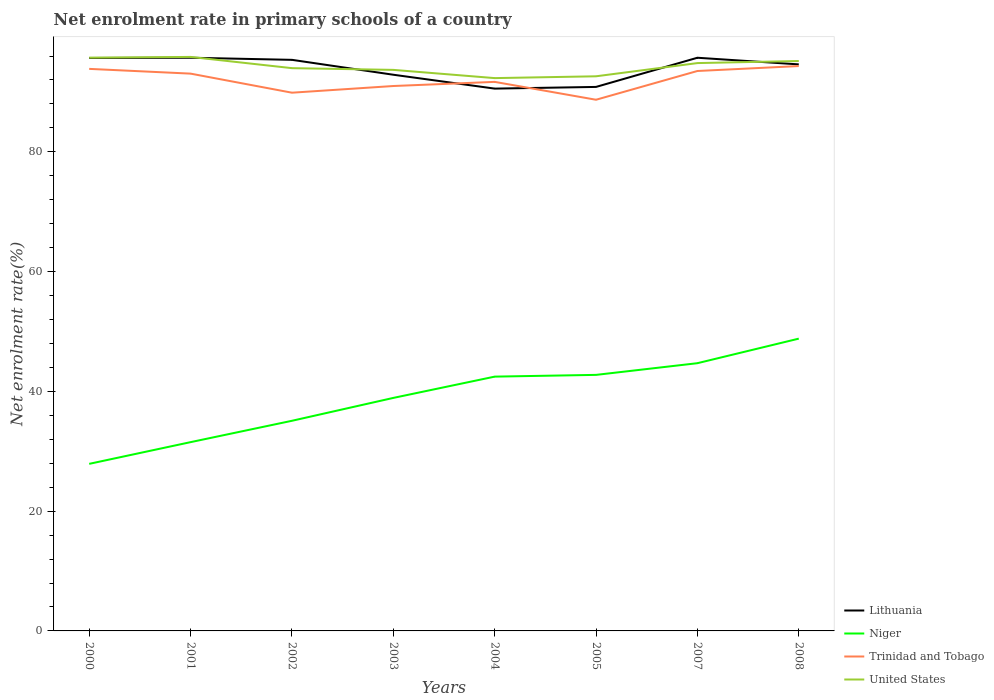Is the number of lines equal to the number of legend labels?
Your answer should be compact. Yes. Across all years, what is the maximum net enrolment rate in primary schools in Niger?
Make the answer very short. 27.9. What is the total net enrolment rate in primary schools in Trinidad and Tobago in the graph?
Ensure brevity in your answer.  -0.69. What is the difference between the highest and the second highest net enrolment rate in primary schools in United States?
Your answer should be very brief. 3.54. What is the difference between the highest and the lowest net enrolment rate in primary schools in Trinidad and Tobago?
Make the answer very short. 4. Is the net enrolment rate in primary schools in Lithuania strictly greater than the net enrolment rate in primary schools in United States over the years?
Offer a very short reply. No. What is the difference between two consecutive major ticks on the Y-axis?
Offer a very short reply. 20. Where does the legend appear in the graph?
Keep it short and to the point. Bottom right. How many legend labels are there?
Keep it short and to the point. 4. What is the title of the graph?
Provide a succinct answer. Net enrolment rate in primary schools of a country. Does "South Asia" appear as one of the legend labels in the graph?
Your answer should be compact. No. What is the label or title of the X-axis?
Provide a succinct answer. Years. What is the label or title of the Y-axis?
Give a very brief answer. Net enrolment rate(%). What is the Net enrolment rate(%) of Lithuania in 2000?
Make the answer very short. 95.68. What is the Net enrolment rate(%) in Niger in 2000?
Provide a succinct answer. 27.9. What is the Net enrolment rate(%) of Trinidad and Tobago in 2000?
Provide a succinct answer. 93.86. What is the Net enrolment rate(%) of United States in 2000?
Ensure brevity in your answer.  95.73. What is the Net enrolment rate(%) in Lithuania in 2001?
Offer a terse response. 95.72. What is the Net enrolment rate(%) in Niger in 2001?
Your answer should be compact. 31.52. What is the Net enrolment rate(%) of Trinidad and Tobago in 2001?
Ensure brevity in your answer.  93.06. What is the Net enrolment rate(%) of United States in 2001?
Offer a very short reply. 95.85. What is the Net enrolment rate(%) of Lithuania in 2002?
Your response must be concise. 95.37. What is the Net enrolment rate(%) in Niger in 2002?
Your answer should be compact. 35.09. What is the Net enrolment rate(%) of Trinidad and Tobago in 2002?
Provide a succinct answer. 89.88. What is the Net enrolment rate(%) in United States in 2002?
Offer a terse response. 93.98. What is the Net enrolment rate(%) of Lithuania in 2003?
Give a very brief answer. 92.88. What is the Net enrolment rate(%) of Niger in 2003?
Your answer should be very brief. 38.91. What is the Net enrolment rate(%) in Trinidad and Tobago in 2003?
Your answer should be compact. 90.99. What is the Net enrolment rate(%) of United States in 2003?
Your answer should be compact. 93.69. What is the Net enrolment rate(%) in Lithuania in 2004?
Provide a succinct answer. 90.56. What is the Net enrolment rate(%) in Niger in 2004?
Provide a succinct answer. 42.46. What is the Net enrolment rate(%) of Trinidad and Tobago in 2004?
Your response must be concise. 91.68. What is the Net enrolment rate(%) of United States in 2004?
Give a very brief answer. 92.31. What is the Net enrolment rate(%) of Lithuania in 2005?
Offer a very short reply. 90.84. What is the Net enrolment rate(%) of Niger in 2005?
Give a very brief answer. 42.76. What is the Net enrolment rate(%) of Trinidad and Tobago in 2005?
Ensure brevity in your answer.  88.7. What is the Net enrolment rate(%) of United States in 2005?
Make the answer very short. 92.62. What is the Net enrolment rate(%) of Lithuania in 2007?
Keep it short and to the point. 95.71. What is the Net enrolment rate(%) in Niger in 2007?
Your response must be concise. 44.71. What is the Net enrolment rate(%) in Trinidad and Tobago in 2007?
Make the answer very short. 93.5. What is the Net enrolment rate(%) of United States in 2007?
Make the answer very short. 94.82. What is the Net enrolment rate(%) of Lithuania in 2008?
Keep it short and to the point. 94.61. What is the Net enrolment rate(%) in Niger in 2008?
Make the answer very short. 48.81. What is the Net enrolment rate(%) in Trinidad and Tobago in 2008?
Offer a terse response. 94.33. What is the Net enrolment rate(%) of United States in 2008?
Your answer should be very brief. 95.17. Across all years, what is the maximum Net enrolment rate(%) in Lithuania?
Provide a succinct answer. 95.72. Across all years, what is the maximum Net enrolment rate(%) of Niger?
Provide a succinct answer. 48.81. Across all years, what is the maximum Net enrolment rate(%) in Trinidad and Tobago?
Offer a terse response. 94.33. Across all years, what is the maximum Net enrolment rate(%) of United States?
Your answer should be compact. 95.85. Across all years, what is the minimum Net enrolment rate(%) of Lithuania?
Provide a succinct answer. 90.56. Across all years, what is the minimum Net enrolment rate(%) of Niger?
Give a very brief answer. 27.9. Across all years, what is the minimum Net enrolment rate(%) in Trinidad and Tobago?
Offer a very short reply. 88.7. Across all years, what is the minimum Net enrolment rate(%) in United States?
Offer a very short reply. 92.31. What is the total Net enrolment rate(%) of Lithuania in the graph?
Keep it short and to the point. 751.36. What is the total Net enrolment rate(%) in Niger in the graph?
Make the answer very short. 312.16. What is the total Net enrolment rate(%) of Trinidad and Tobago in the graph?
Your answer should be very brief. 736.01. What is the total Net enrolment rate(%) in United States in the graph?
Offer a very short reply. 754.18. What is the difference between the Net enrolment rate(%) in Lithuania in 2000 and that in 2001?
Offer a terse response. -0.04. What is the difference between the Net enrolment rate(%) of Niger in 2000 and that in 2001?
Your answer should be very brief. -3.62. What is the difference between the Net enrolment rate(%) of Trinidad and Tobago in 2000 and that in 2001?
Give a very brief answer. 0.79. What is the difference between the Net enrolment rate(%) in United States in 2000 and that in 2001?
Offer a terse response. -0.12. What is the difference between the Net enrolment rate(%) in Lithuania in 2000 and that in 2002?
Make the answer very short. 0.31. What is the difference between the Net enrolment rate(%) in Niger in 2000 and that in 2002?
Keep it short and to the point. -7.19. What is the difference between the Net enrolment rate(%) in Trinidad and Tobago in 2000 and that in 2002?
Provide a short and direct response. 3.98. What is the difference between the Net enrolment rate(%) in United States in 2000 and that in 2002?
Keep it short and to the point. 1.75. What is the difference between the Net enrolment rate(%) of Lithuania in 2000 and that in 2003?
Give a very brief answer. 2.8. What is the difference between the Net enrolment rate(%) in Niger in 2000 and that in 2003?
Your response must be concise. -11.01. What is the difference between the Net enrolment rate(%) of Trinidad and Tobago in 2000 and that in 2003?
Provide a succinct answer. 2.86. What is the difference between the Net enrolment rate(%) of United States in 2000 and that in 2003?
Your answer should be very brief. 2.04. What is the difference between the Net enrolment rate(%) of Lithuania in 2000 and that in 2004?
Your response must be concise. 5.11. What is the difference between the Net enrolment rate(%) in Niger in 2000 and that in 2004?
Provide a succinct answer. -14.57. What is the difference between the Net enrolment rate(%) in Trinidad and Tobago in 2000 and that in 2004?
Your answer should be very brief. 2.17. What is the difference between the Net enrolment rate(%) of United States in 2000 and that in 2004?
Your answer should be compact. 3.41. What is the difference between the Net enrolment rate(%) of Lithuania in 2000 and that in 2005?
Make the answer very short. 4.83. What is the difference between the Net enrolment rate(%) of Niger in 2000 and that in 2005?
Your response must be concise. -14.86. What is the difference between the Net enrolment rate(%) of Trinidad and Tobago in 2000 and that in 2005?
Provide a short and direct response. 5.16. What is the difference between the Net enrolment rate(%) in United States in 2000 and that in 2005?
Your answer should be compact. 3.11. What is the difference between the Net enrolment rate(%) of Lithuania in 2000 and that in 2007?
Your answer should be compact. -0.04. What is the difference between the Net enrolment rate(%) of Niger in 2000 and that in 2007?
Provide a short and direct response. -16.81. What is the difference between the Net enrolment rate(%) of Trinidad and Tobago in 2000 and that in 2007?
Your response must be concise. 0.35. What is the difference between the Net enrolment rate(%) of United States in 2000 and that in 2007?
Provide a succinct answer. 0.91. What is the difference between the Net enrolment rate(%) of Lithuania in 2000 and that in 2008?
Provide a short and direct response. 1.07. What is the difference between the Net enrolment rate(%) of Niger in 2000 and that in 2008?
Offer a terse response. -20.91. What is the difference between the Net enrolment rate(%) in Trinidad and Tobago in 2000 and that in 2008?
Your response must be concise. -0.47. What is the difference between the Net enrolment rate(%) of United States in 2000 and that in 2008?
Offer a terse response. 0.56. What is the difference between the Net enrolment rate(%) in Lithuania in 2001 and that in 2002?
Provide a short and direct response. 0.35. What is the difference between the Net enrolment rate(%) in Niger in 2001 and that in 2002?
Make the answer very short. -3.57. What is the difference between the Net enrolment rate(%) of Trinidad and Tobago in 2001 and that in 2002?
Your response must be concise. 3.18. What is the difference between the Net enrolment rate(%) of United States in 2001 and that in 2002?
Make the answer very short. 1.88. What is the difference between the Net enrolment rate(%) of Lithuania in 2001 and that in 2003?
Your response must be concise. 2.84. What is the difference between the Net enrolment rate(%) of Niger in 2001 and that in 2003?
Your answer should be compact. -7.39. What is the difference between the Net enrolment rate(%) of Trinidad and Tobago in 2001 and that in 2003?
Provide a succinct answer. 2.07. What is the difference between the Net enrolment rate(%) of United States in 2001 and that in 2003?
Provide a succinct answer. 2.16. What is the difference between the Net enrolment rate(%) of Lithuania in 2001 and that in 2004?
Your response must be concise. 5.16. What is the difference between the Net enrolment rate(%) of Niger in 2001 and that in 2004?
Your response must be concise. -10.94. What is the difference between the Net enrolment rate(%) of Trinidad and Tobago in 2001 and that in 2004?
Make the answer very short. 1.38. What is the difference between the Net enrolment rate(%) of United States in 2001 and that in 2004?
Your answer should be very brief. 3.54. What is the difference between the Net enrolment rate(%) of Lithuania in 2001 and that in 2005?
Give a very brief answer. 4.87. What is the difference between the Net enrolment rate(%) of Niger in 2001 and that in 2005?
Offer a very short reply. -11.23. What is the difference between the Net enrolment rate(%) in Trinidad and Tobago in 2001 and that in 2005?
Keep it short and to the point. 4.36. What is the difference between the Net enrolment rate(%) of United States in 2001 and that in 2005?
Your response must be concise. 3.23. What is the difference between the Net enrolment rate(%) of Lithuania in 2001 and that in 2007?
Make the answer very short. 0. What is the difference between the Net enrolment rate(%) of Niger in 2001 and that in 2007?
Your answer should be very brief. -13.19. What is the difference between the Net enrolment rate(%) of Trinidad and Tobago in 2001 and that in 2007?
Your response must be concise. -0.44. What is the difference between the Net enrolment rate(%) of United States in 2001 and that in 2007?
Provide a succinct answer. 1.03. What is the difference between the Net enrolment rate(%) of Lithuania in 2001 and that in 2008?
Give a very brief answer. 1.11. What is the difference between the Net enrolment rate(%) of Niger in 2001 and that in 2008?
Your answer should be very brief. -17.29. What is the difference between the Net enrolment rate(%) of Trinidad and Tobago in 2001 and that in 2008?
Provide a short and direct response. -1.27. What is the difference between the Net enrolment rate(%) of United States in 2001 and that in 2008?
Provide a short and direct response. 0.68. What is the difference between the Net enrolment rate(%) in Lithuania in 2002 and that in 2003?
Provide a succinct answer. 2.49. What is the difference between the Net enrolment rate(%) of Niger in 2002 and that in 2003?
Provide a succinct answer. -3.82. What is the difference between the Net enrolment rate(%) of Trinidad and Tobago in 2002 and that in 2003?
Ensure brevity in your answer.  -1.12. What is the difference between the Net enrolment rate(%) of United States in 2002 and that in 2003?
Keep it short and to the point. 0.29. What is the difference between the Net enrolment rate(%) of Lithuania in 2002 and that in 2004?
Offer a terse response. 4.8. What is the difference between the Net enrolment rate(%) in Niger in 2002 and that in 2004?
Your answer should be compact. -7.37. What is the difference between the Net enrolment rate(%) in Trinidad and Tobago in 2002 and that in 2004?
Keep it short and to the point. -1.81. What is the difference between the Net enrolment rate(%) of United States in 2002 and that in 2004?
Your response must be concise. 1.66. What is the difference between the Net enrolment rate(%) of Lithuania in 2002 and that in 2005?
Your response must be concise. 4.52. What is the difference between the Net enrolment rate(%) in Niger in 2002 and that in 2005?
Your answer should be very brief. -7.67. What is the difference between the Net enrolment rate(%) in Trinidad and Tobago in 2002 and that in 2005?
Your answer should be very brief. 1.18. What is the difference between the Net enrolment rate(%) of United States in 2002 and that in 2005?
Your response must be concise. 1.36. What is the difference between the Net enrolment rate(%) of Lithuania in 2002 and that in 2007?
Your answer should be very brief. -0.35. What is the difference between the Net enrolment rate(%) of Niger in 2002 and that in 2007?
Give a very brief answer. -9.62. What is the difference between the Net enrolment rate(%) of Trinidad and Tobago in 2002 and that in 2007?
Your response must be concise. -3.62. What is the difference between the Net enrolment rate(%) in United States in 2002 and that in 2007?
Offer a very short reply. -0.85. What is the difference between the Net enrolment rate(%) of Lithuania in 2002 and that in 2008?
Ensure brevity in your answer.  0.76. What is the difference between the Net enrolment rate(%) of Niger in 2002 and that in 2008?
Keep it short and to the point. -13.72. What is the difference between the Net enrolment rate(%) in Trinidad and Tobago in 2002 and that in 2008?
Make the answer very short. -4.45. What is the difference between the Net enrolment rate(%) in United States in 2002 and that in 2008?
Provide a short and direct response. -1.2. What is the difference between the Net enrolment rate(%) in Lithuania in 2003 and that in 2004?
Make the answer very short. 2.32. What is the difference between the Net enrolment rate(%) of Niger in 2003 and that in 2004?
Keep it short and to the point. -3.55. What is the difference between the Net enrolment rate(%) of Trinidad and Tobago in 2003 and that in 2004?
Offer a terse response. -0.69. What is the difference between the Net enrolment rate(%) of United States in 2003 and that in 2004?
Offer a terse response. 1.37. What is the difference between the Net enrolment rate(%) in Lithuania in 2003 and that in 2005?
Your answer should be compact. 2.03. What is the difference between the Net enrolment rate(%) in Niger in 2003 and that in 2005?
Offer a very short reply. -3.85. What is the difference between the Net enrolment rate(%) of Trinidad and Tobago in 2003 and that in 2005?
Offer a very short reply. 2.29. What is the difference between the Net enrolment rate(%) in United States in 2003 and that in 2005?
Provide a short and direct response. 1.07. What is the difference between the Net enrolment rate(%) of Lithuania in 2003 and that in 2007?
Give a very brief answer. -2.84. What is the difference between the Net enrolment rate(%) in Niger in 2003 and that in 2007?
Offer a very short reply. -5.8. What is the difference between the Net enrolment rate(%) in Trinidad and Tobago in 2003 and that in 2007?
Your response must be concise. -2.51. What is the difference between the Net enrolment rate(%) of United States in 2003 and that in 2007?
Offer a very short reply. -1.13. What is the difference between the Net enrolment rate(%) in Lithuania in 2003 and that in 2008?
Give a very brief answer. -1.73. What is the difference between the Net enrolment rate(%) of Niger in 2003 and that in 2008?
Your answer should be compact. -9.9. What is the difference between the Net enrolment rate(%) of Trinidad and Tobago in 2003 and that in 2008?
Offer a terse response. -3.33. What is the difference between the Net enrolment rate(%) of United States in 2003 and that in 2008?
Provide a succinct answer. -1.48. What is the difference between the Net enrolment rate(%) of Lithuania in 2004 and that in 2005?
Provide a short and direct response. -0.28. What is the difference between the Net enrolment rate(%) of Niger in 2004 and that in 2005?
Provide a short and direct response. -0.29. What is the difference between the Net enrolment rate(%) of Trinidad and Tobago in 2004 and that in 2005?
Provide a short and direct response. 2.98. What is the difference between the Net enrolment rate(%) in United States in 2004 and that in 2005?
Your answer should be very brief. -0.3. What is the difference between the Net enrolment rate(%) in Lithuania in 2004 and that in 2007?
Keep it short and to the point. -5.15. What is the difference between the Net enrolment rate(%) of Niger in 2004 and that in 2007?
Provide a short and direct response. -2.24. What is the difference between the Net enrolment rate(%) in Trinidad and Tobago in 2004 and that in 2007?
Your answer should be very brief. -1.82. What is the difference between the Net enrolment rate(%) in United States in 2004 and that in 2007?
Provide a succinct answer. -2.51. What is the difference between the Net enrolment rate(%) of Lithuania in 2004 and that in 2008?
Provide a short and direct response. -4.04. What is the difference between the Net enrolment rate(%) of Niger in 2004 and that in 2008?
Provide a short and direct response. -6.34. What is the difference between the Net enrolment rate(%) in Trinidad and Tobago in 2004 and that in 2008?
Keep it short and to the point. -2.64. What is the difference between the Net enrolment rate(%) of United States in 2004 and that in 2008?
Your answer should be very brief. -2.86. What is the difference between the Net enrolment rate(%) of Lithuania in 2005 and that in 2007?
Your response must be concise. -4.87. What is the difference between the Net enrolment rate(%) in Niger in 2005 and that in 2007?
Give a very brief answer. -1.95. What is the difference between the Net enrolment rate(%) in Trinidad and Tobago in 2005 and that in 2007?
Your answer should be compact. -4.8. What is the difference between the Net enrolment rate(%) of United States in 2005 and that in 2007?
Keep it short and to the point. -2.21. What is the difference between the Net enrolment rate(%) in Lithuania in 2005 and that in 2008?
Provide a succinct answer. -3.76. What is the difference between the Net enrolment rate(%) in Niger in 2005 and that in 2008?
Provide a short and direct response. -6.05. What is the difference between the Net enrolment rate(%) in Trinidad and Tobago in 2005 and that in 2008?
Offer a very short reply. -5.63. What is the difference between the Net enrolment rate(%) in United States in 2005 and that in 2008?
Ensure brevity in your answer.  -2.55. What is the difference between the Net enrolment rate(%) of Lithuania in 2007 and that in 2008?
Provide a short and direct response. 1.11. What is the difference between the Net enrolment rate(%) in Niger in 2007 and that in 2008?
Ensure brevity in your answer.  -4.1. What is the difference between the Net enrolment rate(%) in Trinidad and Tobago in 2007 and that in 2008?
Keep it short and to the point. -0.83. What is the difference between the Net enrolment rate(%) in United States in 2007 and that in 2008?
Provide a succinct answer. -0.35. What is the difference between the Net enrolment rate(%) of Lithuania in 2000 and the Net enrolment rate(%) of Niger in 2001?
Ensure brevity in your answer.  64.15. What is the difference between the Net enrolment rate(%) of Lithuania in 2000 and the Net enrolment rate(%) of Trinidad and Tobago in 2001?
Offer a terse response. 2.61. What is the difference between the Net enrolment rate(%) of Lithuania in 2000 and the Net enrolment rate(%) of United States in 2001?
Your response must be concise. -0.18. What is the difference between the Net enrolment rate(%) in Niger in 2000 and the Net enrolment rate(%) in Trinidad and Tobago in 2001?
Offer a very short reply. -65.16. What is the difference between the Net enrolment rate(%) of Niger in 2000 and the Net enrolment rate(%) of United States in 2001?
Your answer should be very brief. -67.95. What is the difference between the Net enrolment rate(%) in Trinidad and Tobago in 2000 and the Net enrolment rate(%) in United States in 2001?
Ensure brevity in your answer.  -2. What is the difference between the Net enrolment rate(%) of Lithuania in 2000 and the Net enrolment rate(%) of Niger in 2002?
Give a very brief answer. 60.59. What is the difference between the Net enrolment rate(%) in Lithuania in 2000 and the Net enrolment rate(%) in Trinidad and Tobago in 2002?
Ensure brevity in your answer.  5.8. What is the difference between the Net enrolment rate(%) of Lithuania in 2000 and the Net enrolment rate(%) of United States in 2002?
Keep it short and to the point. 1.7. What is the difference between the Net enrolment rate(%) of Niger in 2000 and the Net enrolment rate(%) of Trinidad and Tobago in 2002?
Your response must be concise. -61.98. What is the difference between the Net enrolment rate(%) of Niger in 2000 and the Net enrolment rate(%) of United States in 2002?
Give a very brief answer. -66.08. What is the difference between the Net enrolment rate(%) of Trinidad and Tobago in 2000 and the Net enrolment rate(%) of United States in 2002?
Provide a short and direct response. -0.12. What is the difference between the Net enrolment rate(%) of Lithuania in 2000 and the Net enrolment rate(%) of Niger in 2003?
Offer a terse response. 56.77. What is the difference between the Net enrolment rate(%) of Lithuania in 2000 and the Net enrolment rate(%) of Trinidad and Tobago in 2003?
Make the answer very short. 4.68. What is the difference between the Net enrolment rate(%) in Lithuania in 2000 and the Net enrolment rate(%) in United States in 2003?
Ensure brevity in your answer.  1.99. What is the difference between the Net enrolment rate(%) of Niger in 2000 and the Net enrolment rate(%) of Trinidad and Tobago in 2003?
Keep it short and to the point. -63.09. What is the difference between the Net enrolment rate(%) in Niger in 2000 and the Net enrolment rate(%) in United States in 2003?
Your response must be concise. -65.79. What is the difference between the Net enrolment rate(%) of Trinidad and Tobago in 2000 and the Net enrolment rate(%) of United States in 2003?
Keep it short and to the point. 0.17. What is the difference between the Net enrolment rate(%) in Lithuania in 2000 and the Net enrolment rate(%) in Niger in 2004?
Ensure brevity in your answer.  53.21. What is the difference between the Net enrolment rate(%) in Lithuania in 2000 and the Net enrolment rate(%) in Trinidad and Tobago in 2004?
Offer a very short reply. 3.99. What is the difference between the Net enrolment rate(%) in Lithuania in 2000 and the Net enrolment rate(%) in United States in 2004?
Ensure brevity in your answer.  3.36. What is the difference between the Net enrolment rate(%) of Niger in 2000 and the Net enrolment rate(%) of Trinidad and Tobago in 2004?
Provide a short and direct response. -63.79. What is the difference between the Net enrolment rate(%) in Niger in 2000 and the Net enrolment rate(%) in United States in 2004?
Give a very brief answer. -64.42. What is the difference between the Net enrolment rate(%) of Trinidad and Tobago in 2000 and the Net enrolment rate(%) of United States in 2004?
Provide a succinct answer. 1.54. What is the difference between the Net enrolment rate(%) in Lithuania in 2000 and the Net enrolment rate(%) in Niger in 2005?
Provide a short and direct response. 52.92. What is the difference between the Net enrolment rate(%) in Lithuania in 2000 and the Net enrolment rate(%) in Trinidad and Tobago in 2005?
Your answer should be compact. 6.98. What is the difference between the Net enrolment rate(%) of Lithuania in 2000 and the Net enrolment rate(%) of United States in 2005?
Your answer should be very brief. 3.06. What is the difference between the Net enrolment rate(%) in Niger in 2000 and the Net enrolment rate(%) in Trinidad and Tobago in 2005?
Provide a succinct answer. -60.8. What is the difference between the Net enrolment rate(%) in Niger in 2000 and the Net enrolment rate(%) in United States in 2005?
Your response must be concise. -64.72. What is the difference between the Net enrolment rate(%) in Trinidad and Tobago in 2000 and the Net enrolment rate(%) in United States in 2005?
Your response must be concise. 1.24. What is the difference between the Net enrolment rate(%) in Lithuania in 2000 and the Net enrolment rate(%) in Niger in 2007?
Your answer should be compact. 50.97. What is the difference between the Net enrolment rate(%) of Lithuania in 2000 and the Net enrolment rate(%) of Trinidad and Tobago in 2007?
Give a very brief answer. 2.17. What is the difference between the Net enrolment rate(%) of Lithuania in 2000 and the Net enrolment rate(%) of United States in 2007?
Ensure brevity in your answer.  0.85. What is the difference between the Net enrolment rate(%) in Niger in 2000 and the Net enrolment rate(%) in Trinidad and Tobago in 2007?
Make the answer very short. -65.6. What is the difference between the Net enrolment rate(%) in Niger in 2000 and the Net enrolment rate(%) in United States in 2007?
Provide a short and direct response. -66.92. What is the difference between the Net enrolment rate(%) in Trinidad and Tobago in 2000 and the Net enrolment rate(%) in United States in 2007?
Your response must be concise. -0.97. What is the difference between the Net enrolment rate(%) of Lithuania in 2000 and the Net enrolment rate(%) of Niger in 2008?
Offer a very short reply. 46.87. What is the difference between the Net enrolment rate(%) in Lithuania in 2000 and the Net enrolment rate(%) in Trinidad and Tobago in 2008?
Provide a succinct answer. 1.35. What is the difference between the Net enrolment rate(%) of Lithuania in 2000 and the Net enrolment rate(%) of United States in 2008?
Provide a short and direct response. 0.5. What is the difference between the Net enrolment rate(%) in Niger in 2000 and the Net enrolment rate(%) in Trinidad and Tobago in 2008?
Make the answer very short. -66.43. What is the difference between the Net enrolment rate(%) of Niger in 2000 and the Net enrolment rate(%) of United States in 2008?
Give a very brief answer. -67.27. What is the difference between the Net enrolment rate(%) in Trinidad and Tobago in 2000 and the Net enrolment rate(%) in United States in 2008?
Make the answer very short. -1.32. What is the difference between the Net enrolment rate(%) of Lithuania in 2001 and the Net enrolment rate(%) of Niger in 2002?
Provide a short and direct response. 60.63. What is the difference between the Net enrolment rate(%) of Lithuania in 2001 and the Net enrolment rate(%) of Trinidad and Tobago in 2002?
Your answer should be compact. 5.84. What is the difference between the Net enrolment rate(%) in Lithuania in 2001 and the Net enrolment rate(%) in United States in 2002?
Your response must be concise. 1.74. What is the difference between the Net enrolment rate(%) in Niger in 2001 and the Net enrolment rate(%) in Trinidad and Tobago in 2002?
Give a very brief answer. -58.36. What is the difference between the Net enrolment rate(%) of Niger in 2001 and the Net enrolment rate(%) of United States in 2002?
Provide a short and direct response. -62.45. What is the difference between the Net enrolment rate(%) in Trinidad and Tobago in 2001 and the Net enrolment rate(%) in United States in 2002?
Make the answer very short. -0.91. What is the difference between the Net enrolment rate(%) in Lithuania in 2001 and the Net enrolment rate(%) in Niger in 2003?
Make the answer very short. 56.81. What is the difference between the Net enrolment rate(%) of Lithuania in 2001 and the Net enrolment rate(%) of Trinidad and Tobago in 2003?
Give a very brief answer. 4.72. What is the difference between the Net enrolment rate(%) in Lithuania in 2001 and the Net enrolment rate(%) in United States in 2003?
Provide a short and direct response. 2.03. What is the difference between the Net enrolment rate(%) of Niger in 2001 and the Net enrolment rate(%) of Trinidad and Tobago in 2003?
Your response must be concise. -59.47. What is the difference between the Net enrolment rate(%) of Niger in 2001 and the Net enrolment rate(%) of United States in 2003?
Offer a terse response. -62.17. What is the difference between the Net enrolment rate(%) of Trinidad and Tobago in 2001 and the Net enrolment rate(%) of United States in 2003?
Your answer should be compact. -0.63. What is the difference between the Net enrolment rate(%) of Lithuania in 2001 and the Net enrolment rate(%) of Niger in 2004?
Give a very brief answer. 53.25. What is the difference between the Net enrolment rate(%) in Lithuania in 2001 and the Net enrolment rate(%) in Trinidad and Tobago in 2004?
Your response must be concise. 4.03. What is the difference between the Net enrolment rate(%) of Lithuania in 2001 and the Net enrolment rate(%) of United States in 2004?
Keep it short and to the point. 3.4. What is the difference between the Net enrolment rate(%) in Niger in 2001 and the Net enrolment rate(%) in Trinidad and Tobago in 2004?
Make the answer very short. -60.16. What is the difference between the Net enrolment rate(%) of Niger in 2001 and the Net enrolment rate(%) of United States in 2004?
Offer a very short reply. -60.79. What is the difference between the Net enrolment rate(%) of Trinidad and Tobago in 2001 and the Net enrolment rate(%) of United States in 2004?
Provide a short and direct response. 0.75. What is the difference between the Net enrolment rate(%) in Lithuania in 2001 and the Net enrolment rate(%) in Niger in 2005?
Make the answer very short. 52.96. What is the difference between the Net enrolment rate(%) of Lithuania in 2001 and the Net enrolment rate(%) of Trinidad and Tobago in 2005?
Make the answer very short. 7.02. What is the difference between the Net enrolment rate(%) of Lithuania in 2001 and the Net enrolment rate(%) of United States in 2005?
Provide a short and direct response. 3.1. What is the difference between the Net enrolment rate(%) in Niger in 2001 and the Net enrolment rate(%) in Trinidad and Tobago in 2005?
Your answer should be very brief. -57.18. What is the difference between the Net enrolment rate(%) in Niger in 2001 and the Net enrolment rate(%) in United States in 2005?
Your answer should be very brief. -61.1. What is the difference between the Net enrolment rate(%) in Trinidad and Tobago in 2001 and the Net enrolment rate(%) in United States in 2005?
Offer a terse response. 0.44. What is the difference between the Net enrolment rate(%) in Lithuania in 2001 and the Net enrolment rate(%) in Niger in 2007?
Keep it short and to the point. 51.01. What is the difference between the Net enrolment rate(%) of Lithuania in 2001 and the Net enrolment rate(%) of Trinidad and Tobago in 2007?
Your response must be concise. 2.22. What is the difference between the Net enrolment rate(%) in Lithuania in 2001 and the Net enrolment rate(%) in United States in 2007?
Your answer should be very brief. 0.89. What is the difference between the Net enrolment rate(%) in Niger in 2001 and the Net enrolment rate(%) in Trinidad and Tobago in 2007?
Give a very brief answer. -61.98. What is the difference between the Net enrolment rate(%) in Niger in 2001 and the Net enrolment rate(%) in United States in 2007?
Your answer should be very brief. -63.3. What is the difference between the Net enrolment rate(%) in Trinidad and Tobago in 2001 and the Net enrolment rate(%) in United States in 2007?
Your answer should be very brief. -1.76. What is the difference between the Net enrolment rate(%) in Lithuania in 2001 and the Net enrolment rate(%) in Niger in 2008?
Your response must be concise. 46.91. What is the difference between the Net enrolment rate(%) of Lithuania in 2001 and the Net enrolment rate(%) of Trinidad and Tobago in 2008?
Your answer should be compact. 1.39. What is the difference between the Net enrolment rate(%) of Lithuania in 2001 and the Net enrolment rate(%) of United States in 2008?
Offer a very short reply. 0.55. What is the difference between the Net enrolment rate(%) of Niger in 2001 and the Net enrolment rate(%) of Trinidad and Tobago in 2008?
Provide a succinct answer. -62.81. What is the difference between the Net enrolment rate(%) in Niger in 2001 and the Net enrolment rate(%) in United States in 2008?
Ensure brevity in your answer.  -63.65. What is the difference between the Net enrolment rate(%) of Trinidad and Tobago in 2001 and the Net enrolment rate(%) of United States in 2008?
Keep it short and to the point. -2.11. What is the difference between the Net enrolment rate(%) in Lithuania in 2002 and the Net enrolment rate(%) in Niger in 2003?
Offer a terse response. 56.46. What is the difference between the Net enrolment rate(%) of Lithuania in 2002 and the Net enrolment rate(%) of Trinidad and Tobago in 2003?
Keep it short and to the point. 4.37. What is the difference between the Net enrolment rate(%) in Lithuania in 2002 and the Net enrolment rate(%) in United States in 2003?
Provide a short and direct response. 1.68. What is the difference between the Net enrolment rate(%) of Niger in 2002 and the Net enrolment rate(%) of Trinidad and Tobago in 2003?
Offer a very short reply. -55.9. What is the difference between the Net enrolment rate(%) of Niger in 2002 and the Net enrolment rate(%) of United States in 2003?
Ensure brevity in your answer.  -58.6. What is the difference between the Net enrolment rate(%) in Trinidad and Tobago in 2002 and the Net enrolment rate(%) in United States in 2003?
Provide a succinct answer. -3.81. What is the difference between the Net enrolment rate(%) of Lithuania in 2002 and the Net enrolment rate(%) of Niger in 2004?
Your answer should be compact. 52.9. What is the difference between the Net enrolment rate(%) in Lithuania in 2002 and the Net enrolment rate(%) in Trinidad and Tobago in 2004?
Provide a short and direct response. 3.68. What is the difference between the Net enrolment rate(%) of Lithuania in 2002 and the Net enrolment rate(%) of United States in 2004?
Provide a succinct answer. 3.05. What is the difference between the Net enrolment rate(%) of Niger in 2002 and the Net enrolment rate(%) of Trinidad and Tobago in 2004?
Your answer should be compact. -56.59. What is the difference between the Net enrolment rate(%) of Niger in 2002 and the Net enrolment rate(%) of United States in 2004?
Your response must be concise. -57.22. What is the difference between the Net enrolment rate(%) in Trinidad and Tobago in 2002 and the Net enrolment rate(%) in United States in 2004?
Provide a succinct answer. -2.44. What is the difference between the Net enrolment rate(%) in Lithuania in 2002 and the Net enrolment rate(%) in Niger in 2005?
Offer a terse response. 52.61. What is the difference between the Net enrolment rate(%) of Lithuania in 2002 and the Net enrolment rate(%) of Trinidad and Tobago in 2005?
Ensure brevity in your answer.  6.66. What is the difference between the Net enrolment rate(%) in Lithuania in 2002 and the Net enrolment rate(%) in United States in 2005?
Offer a terse response. 2.75. What is the difference between the Net enrolment rate(%) in Niger in 2002 and the Net enrolment rate(%) in Trinidad and Tobago in 2005?
Your response must be concise. -53.61. What is the difference between the Net enrolment rate(%) of Niger in 2002 and the Net enrolment rate(%) of United States in 2005?
Your answer should be compact. -57.53. What is the difference between the Net enrolment rate(%) in Trinidad and Tobago in 2002 and the Net enrolment rate(%) in United States in 2005?
Keep it short and to the point. -2.74. What is the difference between the Net enrolment rate(%) in Lithuania in 2002 and the Net enrolment rate(%) in Niger in 2007?
Your answer should be very brief. 50.66. What is the difference between the Net enrolment rate(%) in Lithuania in 2002 and the Net enrolment rate(%) in Trinidad and Tobago in 2007?
Your answer should be very brief. 1.86. What is the difference between the Net enrolment rate(%) in Lithuania in 2002 and the Net enrolment rate(%) in United States in 2007?
Your answer should be very brief. 0.54. What is the difference between the Net enrolment rate(%) of Niger in 2002 and the Net enrolment rate(%) of Trinidad and Tobago in 2007?
Give a very brief answer. -58.41. What is the difference between the Net enrolment rate(%) of Niger in 2002 and the Net enrolment rate(%) of United States in 2007?
Your answer should be very brief. -59.73. What is the difference between the Net enrolment rate(%) of Trinidad and Tobago in 2002 and the Net enrolment rate(%) of United States in 2007?
Provide a short and direct response. -4.95. What is the difference between the Net enrolment rate(%) in Lithuania in 2002 and the Net enrolment rate(%) in Niger in 2008?
Ensure brevity in your answer.  46.56. What is the difference between the Net enrolment rate(%) in Lithuania in 2002 and the Net enrolment rate(%) in Trinidad and Tobago in 2008?
Offer a terse response. 1.04. What is the difference between the Net enrolment rate(%) in Lithuania in 2002 and the Net enrolment rate(%) in United States in 2008?
Your answer should be very brief. 0.19. What is the difference between the Net enrolment rate(%) in Niger in 2002 and the Net enrolment rate(%) in Trinidad and Tobago in 2008?
Keep it short and to the point. -59.24. What is the difference between the Net enrolment rate(%) in Niger in 2002 and the Net enrolment rate(%) in United States in 2008?
Your response must be concise. -60.08. What is the difference between the Net enrolment rate(%) in Trinidad and Tobago in 2002 and the Net enrolment rate(%) in United States in 2008?
Keep it short and to the point. -5.29. What is the difference between the Net enrolment rate(%) of Lithuania in 2003 and the Net enrolment rate(%) of Niger in 2004?
Provide a succinct answer. 50.41. What is the difference between the Net enrolment rate(%) of Lithuania in 2003 and the Net enrolment rate(%) of Trinidad and Tobago in 2004?
Keep it short and to the point. 1.19. What is the difference between the Net enrolment rate(%) of Lithuania in 2003 and the Net enrolment rate(%) of United States in 2004?
Your answer should be very brief. 0.56. What is the difference between the Net enrolment rate(%) in Niger in 2003 and the Net enrolment rate(%) in Trinidad and Tobago in 2004?
Your answer should be compact. -52.77. What is the difference between the Net enrolment rate(%) in Niger in 2003 and the Net enrolment rate(%) in United States in 2004?
Keep it short and to the point. -53.41. What is the difference between the Net enrolment rate(%) in Trinidad and Tobago in 2003 and the Net enrolment rate(%) in United States in 2004?
Provide a short and direct response. -1.32. What is the difference between the Net enrolment rate(%) of Lithuania in 2003 and the Net enrolment rate(%) of Niger in 2005?
Make the answer very short. 50.12. What is the difference between the Net enrolment rate(%) of Lithuania in 2003 and the Net enrolment rate(%) of Trinidad and Tobago in 2005?
Give a very brief answer. 4.18. What is the difference between the Net enrolment rate(%) in Lithuania in 2003 and the Net enrolment rate(%) in United States in 2005?
Keep it short and to the point. 0.26. What is the difference between the Net enrolment rate(%) in Niger in 2003 and the Net enrolment rate(%) in Trinidad and Tobago in 2005?
Provide a succinct answer. -49.79. What is the difference between the Net enrolment rate(%) of Niger in 2003 and the Net enrolment rate(%) of United States in 2005?
Your answer should be very brief. -53.71. What is the difference between the Net enrolment rate(%) of Trinidad and Tobago in 2003 and the Net enrolment rate(%) of United States in 2005?
Keep it short and to the point. -1.62. What is the difference between the Net enrolment rate(%) in Lithuania in 2003 and the Net enrolment rate(%) in Niger in 2007?
Ensure brevity in your answer.  48.17. What is the difference between the Net enrolment rate(%) of Lithuania in 2003 and the Net enrolment rate(%) of Trinidad and Tobago in 2007?
Keep it short and to the point. -0.62. What is the difference between the Net enrolment rate(%) in Lithuania in 2003 and the Net enrolment rate(%) in United States in 2007?
Keep it short and to the point. -1.95. What is the difference between the Net enrolment rate(%) of Niger in 2003 and the Net enrolment rate(%) of Trinidad and Tobago in 2007?
Your answer should be compact. -54.59. What is the difference between the Net enrolment rate(%) of Niger in 2003 and the Net enrolment rate(%) of United States in 2007?
Your answer should be very brief. -55.91. What is the difference between the Net enrolment rate(%) of Trinidad and Tobago in 2003 and the Net enrolment rate(%) of United States in 2007?
Provide a succinct answer. -3.83. What is the difference between the Net enrolment rate(%) in Lithuania in 2003 and the Net enrolment rate(%) in Niger in 2008?
Your response must be concise. 44.07. What is the difference between the Net enrolment rate(%) of Lithuania in 2003 and the Net enrolment rate(%) of Trinidad and Tobago in 2008?
Offer a very short reply. -1.45. What is the difference between the Net enrolment rate(%) of Lithuania in 2003 and the Net enrolment rate(%) of United States in 2008?
Your answer should be compact. -2.29. What is the difference between the Net enrolment rate(%) in Niger in 2003 and the Net enrolment rate(%) in Trinidad and Tobago in 2008?
Your response must be concise. -55.42. What is the difference between the Net enrolment rate(%) in Niger in 2003 and the Net enrolment rate(%) in United States in 2008?
Ensure brevity in your answer.  -56.26. What is the difference between the Net enrolment rate(%) in Trinidad and Tobago in 2003 and the Net enrolment rate(%) in United States in 2008?
Offer a terse response. -4.18. What is the difference between the Net enrolment rate(%) in Lithuania in 2004 and the Net enrolment rate(%) in Niger in 2005?
Provide a short and direct response. 47.81. What is the difference between the Net enrolment rate(%) of Lithuania in 2004 and the Net enrolment rate(%) of Trinidad and Tobago in 2005?
Offer a very short reply. 1.86. What is the difference between the Net enrolment rate(%) of Lithuania in 2004 and the Net enrolment rate(%) of United States in 2005?
Your response must be concise. -2.06. What is the difference between the Net enrolment rate(%) of Niger in 2004 and the Net enrolment rate(%) of Trinidad and Tobago in 2005?
Offer a terse response. -46.24. What is the difference between the Net enrolment rate(%) in Niger in 2004 and the Net enrolment rate(%) in United States in 2005?
Ensure brevity in your answer.  -50.15. What is the difference between the Net enrolment rate(%) in Trinidad and Tobago in 2004 and the Net enrolment rate(%) in United States in 2005?
Your answer should be very brief. -0.93. What is the difference between the Net enrolment rate(%) in Lithuania in 2004 and the Net enrolment rate(%) in Niger in 2007?
Keep it short and to the point. 45.85. What is the difference between the Net enrolment rate(%) in Lithuania in 2004 and the Net enrolment rate(%) in Trinidad and Tobago in 2007?
Give a very brief answer. -2.94. What is the difference between the Net enrolment rate(%) in Lithuania in 2004 and the Net enrolment rate(%) in United States in 2007?
Keep it short and to the point. -4.26. What is the difference between the Net enrolment rate(%) of Niger in 2004 and the Net enrolment rate(%) of Trinidad and Tobago in 2007?
Your answer should be very brief. -51.04. What is the difference between the Net enrolment rate(%) of Niger in 2004 and the Net enrolment rate(%) of United States in 2007?
Your response must be concise. -52.36. What is the difference between the Net enrolment rate(%) in Trinidad and Tobago in 2004 and the Net enrolment rate(%) in United States in 2007?
Keep it short and to the point. -3.14. What is the difference between the Net enrolment rate(%) of Lithuania in 2004 and the Net enrolment rate(%) of Niger in 2008?
Your response must be concise. 41.75. What is the difference between the Net enrolment rate(%) of Lithuania in 2004 and the Net enrolment rate(%) of Trinidad and Tobago in 2008?
Keep it short and to the point. -3.77. What is the difference between the Net enrolment rate(%) in Lithuania in 2004 and the Net enrolment rate(%) in United States in 2008?
Give a very brief answer. -4.61. What is the difference between the Net enrolment rate(%) in Niger in 2004 and the Net enrolment rate(%) in Trinidad and Tobago in 2008?
Give a very brief answer. -51.86. What is the difference between the Net enrolment rate(%) of Niger in 2004 and the Net enrolment rate(%) of United States in 2008?
Ensure brevity in your answer.  -52.71. What is the difference between the Net enrolment rate(%) of Trinidad and Tobago in 2004 and the Net enrolment rate(%) of United States in 2008?
Provide a succinct answer. -3.49. What is the difference between the Net enrolment rate(%) of Lithuania in 2005 and the Net enrolment rate(%) of Niger in 2007?
Make the answer very short. 46.14. What is the difference between the Net enrolment rate(%) of Lithuania in 2005 and the Net enrolment rate(%) of Trinidad and Tobago in 2007?
Your answer should be very brief. -2.66. What is the difference between the Net enrolment rate(%) of Lithuania in 2005 and the Net enrolment rate(%) of United States in 2007?
Ensure brevity in your answer.  -3.98. What is the difference between the Net enrolment rate(%) in Niger in 2005 and the Net enrolment rate(%) in Trinidad and Tobago in 2007?
Your response must be concise. -50.75. What is the difference between the Net enrolment rate(%) of Niger in 2005 and the Net enrolment rate(%) of United States in 2007?
Ensure brevity in your answer.  -52.07. What is the difference between the Net enrolment rate(%) in Trinidad and Tobago in 2005 and the Net enrolment rate(%) in United States in 2007?
Provide a succinct answer. -6.12. What is the difference between the Net enrolment rate(%) of Lithuania in 2005 and the Net enrolment rate(%) of Niger in 2008?
Offer a very short reply. 42.04. What is the difference between the Net enrolment rate(%) in Lithuania in 2005 and the Net enrolment rate(%) in Trinidad and Tobago in 2008?
Provide a short and direct response. -3.48. What is the difference between the Net enrolment rate(%) in Lithuania in 2005 and the Net enrolment rate(%) in United States in 2008?
Offer a very short reply. -4.33. What is the difference between the Net enrolment rate(%) in Niger in 2005 and the Net enrolment rate(%) in Trinidad and Tobago in 2008?
Make the answer very short. -51.57. What is the difference between the Net enrolment rate(%) of Niger in 2005 and the Net enrolment rate(%) of United States in 2008?
Your response must be concise. -52.42. What is the difference between the Net enrolment rate(%) of Trinidad and Tobago in 2005 and the Net enrolment rate(%) of United States in 2008?
Make the answer very short. -6.47. What is the difference between the Net enrolment rate(%) of Lithuania in 2007 and the Net enrolment rate(%) of Niger in 2008?
Ensure brevity in your answer.  46.91. What is the difference between the Net enrolment rate(%) in Lithuania in 2007 and the Net enrolment rate(%) in Trinidad and Tobago in 2008?
Provide a short and direct response. 1.39. What is the difference between the Net enrolment rate(%) in Lithuania in 2007 and the Net enrolment rate(%) in United States in 2008?
Keep it short and to the point. 0.54. What is the difference between the Net enrolment rate(%) in Niger in 2007 and the Net enrolment rate(%) in Trinidad and Tobago in 2008?
Give a very brief answer. -49.62. What is the difference between the Net enrolment rate(%) of Niger in 2007 and the Net enrolment rate(%) of United States in 2008?
Make the answer very short. -50.46. What is the difference between the Net enrolment rate(%) in Trinidad and Tobago in 2007 and the Net enrolment rate(%) in United States in 2008?
Your response must be concise. -1.67. What is the average Net enrolment rate(%) in Lithuania per year?
Your response must be concise. 93.92. What is the average Net enrolment rate(%) of Niger per year?
Provide a succinct answer. 39.02. What is the average Net enrolment rate(%) of Trinidad and Tobago per year?
Your response must be concise. 92. What is the average Net enrolment rate(%) of United States per year?
Your answer should be compact. 94.27. In the year 2000, what is the difference between the Net enrolment rate(%) in Lithuania and Net enrolment rate(%) in Niger?
Your response must be concise. 67.78. In the year 2000, what is the difference between the Net enrolment rate(%) in Lithuania and Net enrolment rate(%) in Trinidad and Tobago?
Your answer should be very brief. 1.82. In the year 2000, what is the difference between the Net enrolment rate(%) of Lithuania and Net enrolment rate(%) of United States?
Your answer should be very brief. -0.05. In the year 2000, what is the difference between the Net enrolment rate(%) of Niger and Net enrolment rate(%) of Trinidad and Tobago?
Your response must be concise. -65.96. In the year 2000, what is the difference between the Net enrolment rate(%) of Niger and Net enrolment rate(%) of United States?
Your answer should be compact. -67.83. In the year 2000, what is the difference between the Net enrolment rate(%) in Trinidad and Tobago and Net enrolment rate(%) in United States?
Your answer should be compact. -1.87. In the year 2001, what is the difference between the Net enrolment rate(%) in Lithuania and Net enrolment rate(%) in Niger?
Keep it short and to the point. 64.2. In the year 2001, what is the difference between the Net enrolment rate(%) of Lithuania and Net enrolment rate(%) of Trinidad and Tobago?
Your answer should be very brief. 2.65. In the year 2001, what is the difference between the Net enrolment rate(%) of Lithuania and Net enrolment rate(%) of United States?
Provide a short and direct response. -0.13. In the year 2001, what is the difference between the Net enrolment rate(%) in Niger and Net enrolment rate(%) in Trinidad and Tobago?
Keep it short and to the point. -61.54. In the year 2001, what is the difference between the Net enrolment rate(%) in Niger and Net enrolment rate(%) in United States?
Provide a short and direct response. -64.33. In the year 2001, what is the difference between the Net enrolment rate(%) in Trinidad and Tobago and Net enrolment rate(%) in United States?
Give a very brief answer. -2.79. In the year 2002, what is the difference between the Net enrolment rate(%) of Lithuania and Net enrolment rate(%) of Niger?
Your answer should be compact. 60.27. In the year 2002, what is the difference between the Net enrolment rate(%) in Lithuania and Net enrolment rate(%) in Trinidad and Tobago?
Your response must be concise. 5.49. In the year 2002, what is the difference between the Net enrolment rate(%) of Lithuania and Net enrolment rate(%) of United States?
Your response must be concise. 1.39. In the year 2002, what is the difference between the Net enrolment rate(%) of Niger and Net enrolment rate(%) of Trinidad and Tobago?
Your answer should be very brief. -54.79. In the year 2002, what is the difference between the Net enrolment rate(%) of Niger and Net enrolment rate(%) of United States?
Make the answer very short. -58.89. In the year 2002, what is the difference between the Net enrolment rate(%) in Trinidad and Tobago and Net enrolment rate(%) in United States?
Ensure brevity in your answer.  -4.1. In the year 2003, what is the difference between the Net enrolment rate(%) of Lithuania and Net enrolment rate(%) of Niger?
Give a very brief answer. 53.97. In the year 2003, what is the difference between the Net enrolment rate(%) of Lithuania and Net enrolment rate(%) of Trinidad and Tobago?
Make the answer very short. 1.88. In the year 2003, what is the difference between the Net enrolment rate(%) in Lithuania and Net enrolment rate(%) in United States?
Offer a terse response. -0.81. In the year 2003, what is the difference between the Net enrolment rate(%) of Niger and Net enrolment rate(%) of Trinidad and Tobago?
Provide a short and direct response. -52.08. In the year 2003, what is the difference between the Net enrolment rate(%) in Niger and Net enrolment rate(%) in United States?
Keep it short and to the point. -54.78. In the year 2003, what is the difference between the Net enrolment rate(%) of Trinidad and Tobago and Net enrolment rate(%) of United States?
Ensure brevity in your answer.  -2.7. In the year 2004, what is the difference between the Net enrolment rate(%) of Lithuania and Net enrolment rate(%) of Niger?
Your response must be concise. 48.1. In the year 2004, what is the difference between the Net enrolment rate(%) in Lithuania and Net enrolment rate(%) in Trinidad and Tobago?
Keep it short and to the point. -1.12. In the year 2004, what is the difference between the Net enrolment rate(%) of Lithuania and Net enrolment rate(%) of United States?
Provide a short and direct response. -1.75. In the year 2004, what is the difference between the Net enrolment rate(%) in Niger and Net enrolment rate(%) in Trinidad and Tobago?
Provide a succinct answer. -49.22. In the year 2004, what is the difference between the Net enrolment rate(%) of Niger and Net enrolment rate(%) of United States?
Make the answer very short. -49.85. In the year 2004, what is the difference between the Net enrolment rate(%) in Trinidad and Tobago and Net enrolment rate(%) in United States?
Ensure brevity in your answer.  -0.63. In the year 2005, what is the difference between the Net enrolment rate(%) of Lithuania and Net enrolment rate(%) of Niger?
Ensure brevity in your answer.  48.09. In the year 2005, what is the difference between the Net enrolment rate(%) of Lithuania and Net enrolment rate(%) of Trinidad and Tobago?
Keep it short and to the point. 2.14. In the year 2005, what is the difference between the Net enrolment rate(%) in Lithuania and Net enrolment rate(%) in United States?
Your response must be concise. -1.77. In the year 2005, what is the difference between the Net enrolment rate(%) in Niger and Net enrolment rate(%) in Trinidad and Tobago?
Your answer should be very brief. -45.94. In the year 2005, what is the difference between the Net enrolment rate(%) in Niger and Net enrolment rate(%) in United States?
Your answer should be very brief. -49.86. In the year 2005, what is the difference between the Net enrolment rate(%) of Trinidad and Tobago and Net enrolment rate(%) of United States?
Ensure brevity in your answer.  -3.92. In the year 2007, what is the difference between the Net enrolment rate(%) of Lithuania and Net enrolment rate(%) of Niger?
Your response must be concise. 51.01. In the year 2007, what is the difference between the Net enrolment rate(%) in Lithuania and Net enrolment rate(%) in Trinidad and Tobago?
Your response must be concise. 2.21. In the year 2007, what is the difference between the Net enrolment rate(%) in Lithuania and Net enrolment rate(%) in United States?
Ensure brevity in your answer.  0.89. In the year 2007, what is the difference between the Net enrolment rate(%) in Niger and Net enrolment rate(%) in Trinidad and Tobago?
Your answer should be compact. -48.79. In the year 2007, what is the difference between the Net enrolment rate(%) in Niger and Net enrolment rate(%) in United States?
Offer a terse response. -50.12. In the year 2007, what is the difference between the Net enrolment rate(%) in Trinidad and Tobago and Net enrolment rate(%) in United States?
Your response must be concise. -1.32. In the year 2008, what is the difference between the Net enrolment rate(%) in Lithuania and Net enrolment rate(%) in Niger?
Keep it short and to the point. 45.8. In the year 2008, what is the difference between the Net enrolment rate(%) of Lithuania and Net enrolment rate(%) of Trinidad and Tobago?
Your answer should be compact. 0.28. In the year 2008, what is the difference between the Net enrolment rate(%) in Lithuania and Net enrolment rate(%) in United States?
Ensure brevity in your answer.  -0.57. In the year 2008, what is the difference between the Net enrolment rate(%) of Niger and Net enrolment rate(%) of Trinidad and Tobago?
Offer a terse response. -45.52. In the year 2008, what is the difference between the Net enrolment rate(%) in Niger and Net enrolment rate(%) in United States?
Provide a short and direct response. -46.37. In the year 2008, what is the difference between the Net enrolment rate(%) of Trinidad and Tobago and Net enrolment rate(%) of United States?
Your response must be concise. -0.84. What is the ratio of the Net enrolment rate(%) of Niger in 2000 to that in 2001?
Offer a terse response. 0.89. What is the ratio of the Net enrolment rate(%) in Trinidad and Tobago in 2000 to that in 2001?
Offer a very short reply. 1.01. What is the ratio of the Net enrolment rate(%) of Niger in 2000 to that in 2002?
Ensure brevity in your answer.  0.8. What is the ratio of the Net enrolment rate(%) of Trinidad and Tobago in 2000 to that in 2002?
Ensure brevity in your answer.  1.04. What is the ratio of the Net enrolment rate(%) of United States in 2000 to that in 2002?
Provide a short and direct response. 1.02. What is the ratio of the Net enrolment rate(%) in Lithuania in 2000 to that in 2003?
Provide a succinct answer. 1.03. What is the ratio of the Net enrolment rate(%) of Niger in 2000 to that in 2003?
Your answer should be compact. 0.72. What is the ratio of the Net enrolment rate(%) in Trinidad and Tobago in 2000 to that in 2003?
Provide a short and direct response. 1.03. What is the ratio of the Net enrolment rate(%) in United States in 2000 to that in 2003?
Make the answer very short. 1.02. What is the ratio of the Net enrolment rate(%) of Lithuania in 2000 to that in 2004?
Give a very brief answer. 1.06. What is the ratio of the Net enrolment rate(%) in Niger in 2000 to that in 2004?
Offer a terse response. 0.66. What is the ratio of the Net enrolment rate(%) in Trinidad and Tobago in 2000 to that in 2004?
Give a very brief answer. 1.02. What is the ratio of the Net enrolment rate(%) in Lithuania in 2000 to that in 2005?
Keep it short and to the point. 1.05. What is the ratio of the Net enrolment rate(%) of Niger in 2000 to that in 2005?
Ensure brevity in your answer.  0.65. What is the ratio of the Net enrolment rate(%) of Trinidad and Tobago in 2000 to that in 2005?
Make the answer very short. 1.06. What is the ratio of the Net enrolment rate(%) of United States in 2000 to that in 2005?
Make the answer very short. 1.03. What is the ratio of the Net enrolment rate(%) in Lithuania in 2000 to that in 2007?
Your response must be concise. 1. What is the ratio of the Net enrolment rate(%) of Niger in 2000 to that in 2007?
Provide a succinct answer. 0.62. What is the ratio of the Net enrolment rate(%) in Trinidad and Tobago in 2000 to that in 2007?
Your response must be concise. 1. What is the ratio of the Net enrolment rate(%) in United States in 2000 to that in 2007?
Give a very brief answer. 1.01. What is the ratio of the Net enrolment rate(%) in Lithuania in 2000 to that in 2008?
Provide a succinct answer. 1.01. What is the ratio of the Net enrolment rate(%) of Niger in 2000 to that in 2008?
Provide a succinct answer. 0.57. What is the ratio of the Net enrolment rate(%) of United States in 2000 to that in 2008?
Your answer should be very brief. 1.01. What is the ratio of the Net enrolment rate(%) in Lithuania in 2001 to that in 2002?
Your answer should be compact. 1. What is the ratio of the Net enrolment rate(%) in Niger in 2001 to that in 2002?
Your answer should be compact. 0.9. What is the ratio of the Net enrolment rate(%) of Trinidad and Tobago in 2001 to that in 2002?
Your answer should be very brief. 1.04. What is the ratio of the Net enrolment rate(%) in United States in 2001 to that in 2002?
Your answer should be compact. 1.02. What is the ratio of the Net enrolment rate(%) of Lithuania in 2001 to that in 2003?
Provide a succinct answer. 1.03. What is the ratio of the Net enrolment rate(%) in Niger in 2001 to that in 2003?
Keep it short and to the point. 0.81. What is the ratio of the Net enrolment rate(%) in Trinidad and Tobago in 2001 to that in 2003?
Keep it short and to the point. 1.02. What is the ratio of the Net enrolment rate(%) in United States in 2001 to that in 2003?
Provide a short and direct response. 1.02. What is the ratio of the Net enrolment rate(%) in Lithuania in 2001 to that in 2004?
Provide a succinct answer. 1.06. What is the ratio of the Net enrolment rate(%) in Niger in 2001 to that in 2004?
Your answer should be very brief. 0.74. What is the ratio of the Net enrolment rate(%) of United States in 2001 to that in 2004?
Offer a very short reply. 1.04. What is the ratio of the Net enrolment rate(%) of Lithuania in 2001 to that in 2005?
Your response must be concise. 1.05. What is the ratio of the Net enrolment rate(%) in Niger in 2001 to that in 2005?
Provide a succinct answer. 0.74. What is the ratio of the Net enrolment rate(%) in Trinidad and Tobago in 2001 to that in 2005?
Provide a succinct answer. 1.05. What is the ratio of the Net enrolment rate(%) in United States in 2001 to that in 2005?
Offer a terse response. 1.03. What is the ratio of the Net enrolment rate(%) of Niger in 2001 to that in 2007?
Offer a very short reply. 0.71. What is the ratio of the Net enrolment rate(%) in United States in 2001 to that in 2007?
Ensure brevity in your answer.  1.01. What is the ratio of the Net enrolment rate(%) of Lithuania in 2001 to that in 2008?
Your answer should be very brief. 1.01. What is the ratio of the Net enrolment rate(%) of Niger in 2001 to that in 2008?
Make the answer very short. 0.65. What is the ratio of the Net enrolment rate(%) in Trinidad and Tobago in 2001 to that in 2008?
Provide a succinct answer. 0.99. What is the ratio of the Net enrolment rate(%) of United States in 2001 to that in 2008?
Offer a terse response. 1.01. What is the ratio of the Net enrolment rate(%) in Lithuania in 2002 to that in 2003?
Keep it short and to the point. 1.03. What is the ratio of the Net enrolment rate(%) in Niger in 2002 to that in 2003?
Make the answer very short. 0.9. What is the ratio of the Net enrolment rate(%) of United States in 2002 to that in 2003?
Ensure brevity in your answer.  1. What is the ratio of the Net enrolment rate(%) in Lithuania in 2002 to that in 2004?
Offer a very short reply. 1.05. What is the ratio of the Net enrolment rate(%) in Niger in 2002 to that in 2004?
Offer a terse response. 0.83. What is the ratio of the Net enrolment rate(%) in Trinidad and Tobago in 2002 to that in 2004?
Provide a succinct answer. 0.98. What is the ratio of the Net enrolment rate(%) of United States in 2002 to that in 2004?
Provide a succinct answer. 1.02. What is the ratio of the Net enrolment rate(%) in Lithuania in 2002 to that in 2005?
Keep it short and to the point. 1.05. What is the ratio of the Net enrolment rate(%) of Niger in 2002 to that in 2005?
Give a very brief answer. 0.82. What is the ratio of the Net enrolment rate(%) of Trinidad and Tobago in 2002 to that in 2005?
Make the answer very short. 1.01. What is the ratio of the Net enrolment rate(%) in United States in 2002 to that in 2005?
Provide a short and direct response. 1.01. What is the ratio of the Net enrolment rate(%) of Niger in 2002 to that in 2007?
Ensure brevity in your answer.  0.78. What is the ratio of the Net enrolment rate(%) in Trinidad and Tobago in 2002 to that in 2007?
Give a very brief answer. 0.96. What is the ratio of the Net enrolment rate(%) in Lithuania in 2002 to that in 2008?
Ensure brevity in your answer.  1.01. What is the ratio of the Net enrolment rate(%) of Niger in 2002 to that in 2008?
Offer a very short reply. 0.72. What is the ratio of the Net enrolment rate(%) of Trinidad and Tobago in 2002 to that in 2008?
Your answer should be very brief. 0.95. What is the ratio of the Net enrolment rate(%) in United States in 2002 to that in 2008?
Make the answer very short. 0.99. What is the ratio of the Net enrolment rate(%) in Lithuania in 2003 to that in 2004?
Ensure brevity in your answer.  1.03. What is the ratio of the Net enrolment rate(%) of Niger in 2003 to that in 2004?
Provide a succinct answer. 0.92. What is the ratio of the Net enrolment rate(%) of Trinidad and Tobago in 2003 to that in 2004?
Provide a succinct answer. 0.99. What is the ratio of the Net enrolment rate(%) of United States in 2003 to that in 2004?
Give a very brief answer. 1.01. What is the ratio of the Net enrolment rate(%) in Lithuania in 2003 to that in 2005?
Offer a terse response. 1.02. What is the ratio of the Net enrolment rate(%) in Niger in 2003 to that in 2005?
Your answer should be compact. 0.91. What is the ratio of the Net enrolment rate(%) in Trinidad and Tobago in 2003 to that in 2005?
Provide a short and direct response. 1.03. What is the ratio of the Net enrolment rate(%) in United States in 2003 to that in 2005?
Ensure brevity in your answer.  1.01. What is the ratio of the Net enrolment rate(%) of Lithuania in 2003 to that in 2007?
Provide a short and direct response. 0.97. What is the ratio of the Net enrolment rate(%) in Niger in 2003 to that in 2007?
Offer a terse response. 0.87. What is the ratio of the Net enrolment rate(%) in Trinidad and Tobago in 2003 to that in 2007?
Your response must be concise. 0.97. What is the ratio of the Net enrolment rate(%) of United States in 2003 to that in 2007?
Keep it short and to the point. 0.99. What is the ratio of the Net enrolment rate(%) of Lithuania in 2003 to that in 2008?
Offer a terse response. 0.98. What is the ratio of the Net enrolment rate(%) of Niger in 2003 to that in 2008?
Provide a succinct answer. 0.8. What is the ratio of the Net enrolment rate(%) in Trinidad and Tobago in 2003 to that in 2008?
Your answer should be very brief. 0.96. What is the ratio of the Net enrolment rate(%) of United States in 2003 to that in 2008?
Your answer should be very brief. 0.98. What is the ratio of the Net enrolment rate(%) of Trinidad and Tobago in 2004 to that in 2005?
Keep it short and to the point. 1.03. What is the ratio of the Net enrolment rate(%) in Lithuania in 2004 to that in 2007?
Make the answer very short. 0.95. What is the ratio of the Net enrolment rate(%) in Niger in 2004 to that in 2007?
Give a very brief answer. 0.95. What is the ratio of the Net enrolment rate(%) in Trinidad and Tobago in 2004 to that in 2007?
Ensure brevity in your answer.  0.98. What is the ratio of the Net enrolment rate(%) in United States in 2004 to that in 2007?
Give a very brief answer. 0.97. What is the ratio of the Net enrolment rate(%) of Lithuania in 2004 to that in 2008?
Provide a succinct answer. 0.96. What is the ratio of the Net enrolment rate(%) in Niger in 2004 to that in 2008?
Your response must be concise. 0.87. What is the ratio of the Net enrolment rate(%) in Trinidad and Tobago in 2004 to that in 2008?
Offer a very short reply. 0.97. What is the ratio of the Net enrolment rate(%) of Lithuania in 2005 to that in 2007?
Your answer should be compact. 0.95. What is the ratio of the Net enrolment rate(%) in Niger in 2005 to that in 2007?
Your response must be concise. 0.96. What is the ratio of the Net enrolment rate(%) of Trinidad and Tobago in 2005 to that in 2007?
Give a very brief answer. 0.95. What is the ratio of the Net enrolment rate(%) of United States in 2005 to that in 2007?
Make the answer very short. 0.98. What is the ratio of the Net enrolment rate(%) of Lithuania in 2005 to that in 2008?
Give a very brief answer. 0.96. What is the ratio of the Net enrolment rate(%) of Niger in 2005 to that in 2008?
Offer a terse response. 0.88. What is the ratio of the Net enrolment rate(%) in Trinidad and Tobago in 2005 to that in 2008?
Make the answer very short. 0.94. What is the ratio of the Net enrolment rate(%) of United States in 2005 to that in 2008?
Ensure brevity in your answer.  0.97. What is the ratio of the Net enrolment rate(%) in Lithuania in 2007 to that in 2008?
Give a very brief answer. 1.01. What is the ratio of the Net enrolment rate(%) of Niger in 2007 to that in 2008?
Your answer should be very brief. 0.92. What is the difference between the highest and the second highest Net enrolment rate(%) of Lithuania?
Offer a terse response. 0. What is the difference between the highest and the second highest Net enrolment rate(%) of Niger?
Keep it short and to the point. 4.1. What is the difference between the highest and the second highest Net enrolment rate(%) of Trinidad and Tobago?
Keep it short and to the point. 0.47. What is the difference between the highest and the second highest Net enrolment rate(%) in United States?
Keep it short and to the point. 0.12. What is the difference between the highest and the lowest Net enrolment rate(%) in Lithuania?
Make the answer very short. 5.16. What is the difference between the highest and the lowest Net enrolment rate(%) of Niger?
Offer a terse response. 20.91. What is the difference between the highest and the lowest Net enrolment rate(%) in Trinidad and Tobago?
Your answer should be very brief. 5.63. What is the difference between the highest and the lowest Net enrolment rate(%) in United States?
Offer a terse response. 3.54. 